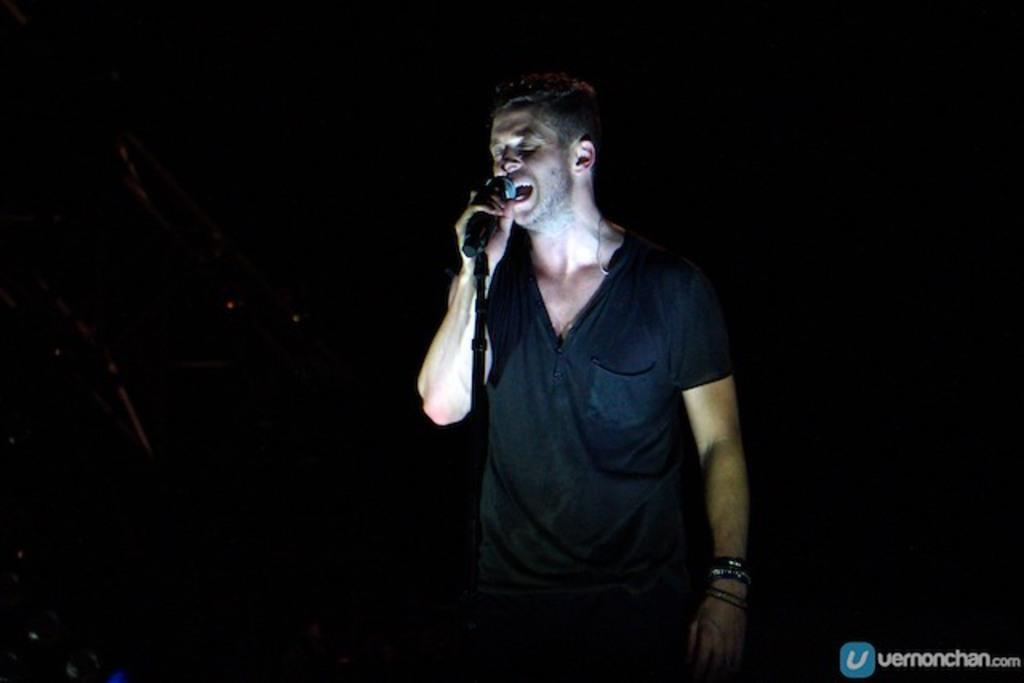What is the main subject of the image? There is a man in the image. What is the man wearing? The man is wearing a black shirt. What is the man holding in the image? The man is holding a microphone. What is the man doing in the image? The man is singing. How would you describe the lighting in the image? The image is taken in a dark environment. What type of sweater is the man wearing in the image? The man is not wearing a sweater in the image; he is wearing a black shirt. Can you see any tomatoes in the image? There are no tomatoes present in the image. 